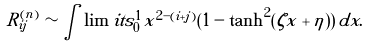<formula> <loc_0><loc_0><loc_500><loc_500>R ^ { ( n ) } _ { i j } \sim \int \lim i t s _ { 0 } ^ { 1 } x ^ { 2 - ( i + j ) } ( 1 - \tanh ^ { 2 } ( \zeta x + \eta ) ) \, d x .</formula> 